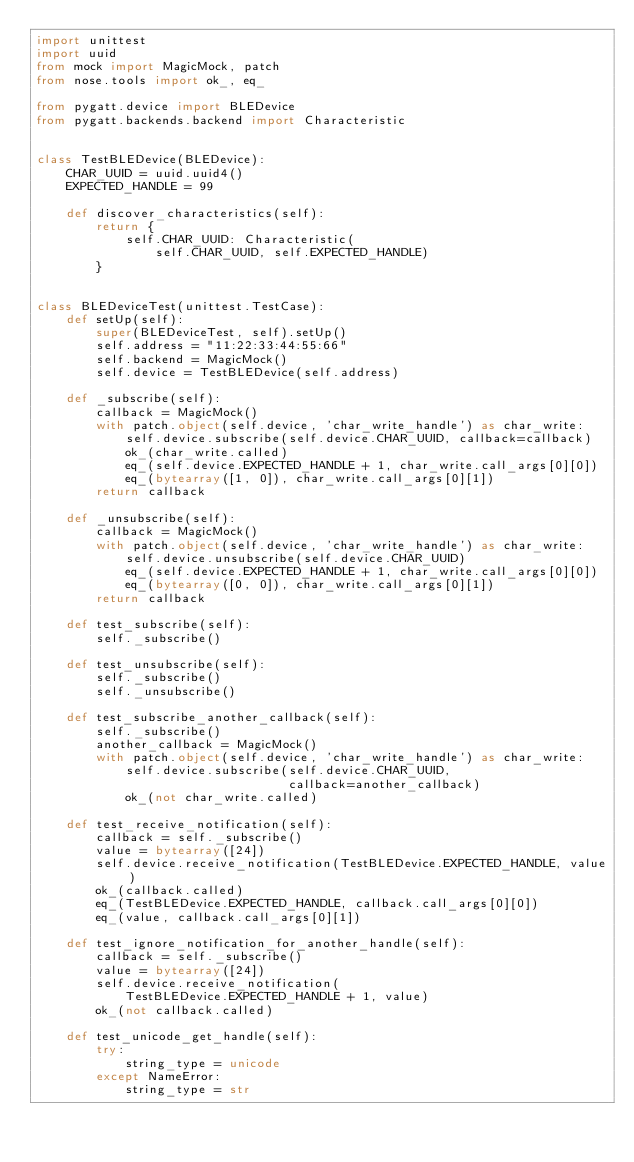<code> <loc_0><loc_0><loc_500><loc_500><_Python_>import unittest
import uuid
from mock import MagicMock, patch
from nose.tools import ok_, eq_

from pygatt.device import BLEDevice
from pygatt.backends.backend import Characteristic


class TestBLEDevice(BLEDevice):
    CHAR_UUID = uuid.uuid4()
    EXPECTED_HANDLE = 99

    def discover_characteristics(self):
        return {
            self.CHAR_UUID: Characteristic(
                self.CHAR_UUID, self.EXPECTED_HANDLE)
        }


class BLEDeviceTest(unittest.TestCase):
    def setUp(self):
        super(BLEDeviceTest, self).setUp()
        self.address = "11:22:33:44:55:66"
        self.backend = MagicMock()
        self.device = TestBLEDevice(self.address)

    def _subscribe(self):
        callback = MagicMock()
        with patch.object(self.device, 'char_write_handle') as char_write:
            self.device.subscribe(self.device.CHAR_UUID, callback=callback)
            ok_(char_write.called)
            eq_(self.device.EXPECTED_HANDLE + 1, char_write.call_args[0][0])
            eq_(bytearray([1, 0]), char_write.call_args[0][1])
        return callback

    def _unsubscribe(self):
        callback = MagicMock()
        with patch.object(self.device, 'char_write_handle') as char_write:
            self.device.unsubscribe(self.device.CHAR_UUID)
            eq_(self.device.EXPECTED_HANDLE + 1, char_write.call_args[0][0])
            eq_(bytearray([0, 0]), char_write.call_args[0][1])
        return callback

    def test_subscribe(self):
        self._subscribe()

    def test_unsubscribe(self):
        self._subscribe()
        self._unsubscribe()

    def test_subscribe_another_callback(self):
        self._subscribe()
        another_callback = MagicMock()
        with patch.object(self.device, 'char_write_handle') as char_write:
            self.device.subscribe(self.device.CHAR_UUID,
                                  callback=another_callback)
            ok_(not char_write.called)

    def test_receive_notification(self):
        callback = self._subscribe()
        value = bytearray([24])
        self.device.receive_notification(TestBLEDevice.EXPECTED_HANDLE, value)
        ok_(callback.called)
        eq_(TestBLEDevice.EXPECTED_HANDLE, callback.call_args[0][0])
        eq_(value, callback.call_args[0][1])

    def test_ignore_notification_for_another_handle(self):
        callback = self._subscribe()
        value = bytearray([24])
        self.device.receive_notification(
            TestBLEDevice.EXPECTED_HANDLE + 1, value)
        ok_(not callback.called)

    def test_unicode_get_handle(self):
        try:
            string_type = unicode
        except NameError:
            string_type = str
</code> 